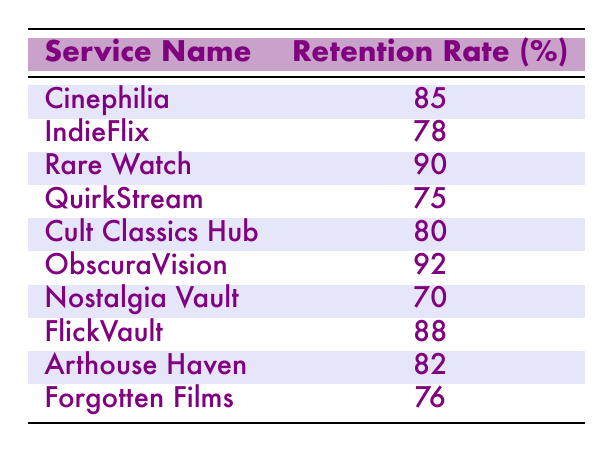What is the retention rate for Rare Watch? By looking at the table, I can see that the row for Rare Watch shows a retention rate of 90%.
Answer: 90 Which streaming service has the highest retention rate? ObscuraVision has the highest retention rate listed in the table, which is 92%.
Answer: 92 What is the average retention rate of all services? First, add together all the retention rates: 85 + 78 + 90 + 75 + 80 + 92 + 70 + 88 + 82 + 76 =  835. Then, divide by the number of services (10) to find the average: 835 / 10 = 83.5.
Answer: 83.5 Is the retention rate for FlickVault higher than that of IndieFlix? FlickVault has a retention rate of 88%, while IndieFlix has 78%. Since 88 is greater than 78, the statement is true.
Answer: Yes What is the total retention rate of all services combined? To find the total retention rate, sum the retention rates of all services: 85 + 78 + 90 + 75 + 80 + 92 + 70 + 88 + 82 + 76 =  835.
Answer: 835 How many services have a retention rate above 80%? The services with retention rates above 80% are Cinephilia (85), Rare Watch (90), ObscuraVision (92), FlickVault (88), and Arthouse Haven (82). This totals to 5 services.
Answer: 5 What is the difference in retention rates between the highest and the lowest? The highest retention rate is 92% (ObscuraVision) and the lowest is 70% (Nostalgia Vault). The difference is 92 - 70 = 22.
Answer: 22 Is there a service with a retention rate of 75% or lower? In the table, QuirkStream has a retention rate of 75% and Nostalgia Vault has 70%, so there are services below 75%.
Answer: Yes What service is closest to the average retention rate of 83.5? The services with retention rates nearest to 83.5 are Cinephilia (85) and Arthouse Haven (82), as they are the closest values to the average.
Answer: Cinephilia, Arthouse Haven 